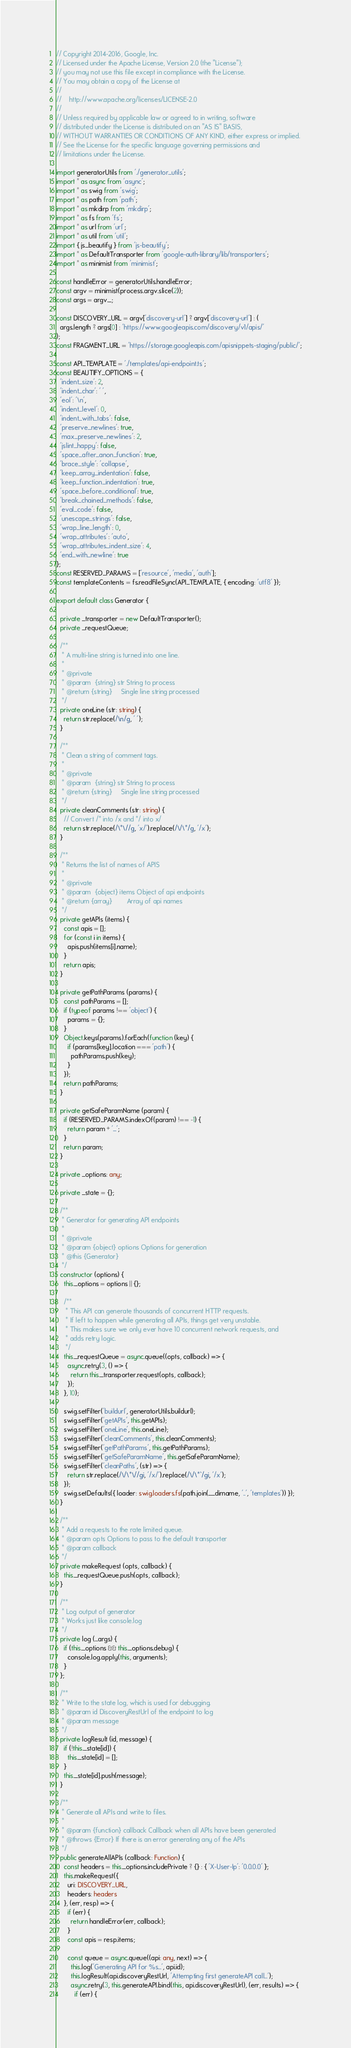Convert code to text. <code><loc_0><loc_0><loc_500><loc_500><_TypeScript_>// Copyright 2014-2016, Google, Inc.
// Licensed under the Apache License, Version 2.0 (the "License");
// you may not use this file except in compliance with the License.
// You may obtain a copy of the License at
//
//    http://www.apache.org/licenses/LICENSE-2.0
//
// Unless required by applicable law or agreed to in writing, software
// distributed under the License is distributed on an "AS IS" BASIS,
// WITHOUT WARRANTIES OR CONDITIONS OF ANY KIND, either express or implied.
// See the License for the specific language governing permissions and
// limitations under the License.

import generatorUtils from './generator_utils';
import * as async from 'async';
import * as swig from 'swig';
import * as path from 'path';
import * as mkdirp from 'mkdirp';
import * as fs from 'fs';
import * as url from 'url';
import * as util from 'util';
import { js_beautify } from 'js-beautify';
import * as DefaultTransporter from 'google-auth-library/lib/transporters';
import * as minimist from 'minimist';

const handleError = generatorUtils.handleError;
const argv = minimist(process.argv.slice(2));
const args = argv._;

const DISCOVERY_URL = argv['discovery-url'] ? argv['discovery-url'] : (
  args.length ? args[0] : 'https://www.googleapis.com/discovery/v1/apis/'
);
const FRAGMENT_URL = 'https://storage.googleapis.com/apisnippets-staging/public/';

const API_TEMPLATE = './templates/api-endpoint.ts';
const BEAUTIFY_OPTIONS = {
  'indent_size': 2,
  'indent_char': ' ',
  'eol': '\n',
  'indent_level': 0,
  'indent_with_tabs': false,
  'preserve_newlines': true,
  'max_preserve_newlines': 2,
  'jslint_happy': false,
  'space_after_anon_function': true,
  'brace_style': 'collapse',
  'keep_array_indentation': false,
  'keep_function_indentation': true,
  'space_before_conditional': true,
  'break_chained_methods': false,
  'eval_code': false,
  'unescape_strings': false,
  'wrap_line_length': 0,
  'wrap_attributes': 'auto',
  'wrap_attributes_indent_size': 4,
  'end_with_newline': true
};
const RESERVED_PARAMS = ['resource', 'media', 'auth'];
const templateContents = fs.readFileSync(API_TEMPLATE, { encoding: 'utf8' });

export default class Generator {

  private _transporter = new DefaultTransporter();
  private _requestQueue;

  /**
   * A multi-line string is turned into one line.
   *
   * @private
   * @param  {string} str String to process
   * @return {string}     Single line string processed
   */
  private oneLine (str: string) {
    return str.replace(/\n/g, ' ');
  }

  /**
   * Clean a string of comment tags.
   *
   * @private
   * @param  {string} str String to process
   * @return {string}     Single line string processed
   */
  private cleanComments (str: string) {
    // Convert /* into /x and */ into x/
    return str.replace(/\*\//g, 'x/').replace(/\/\*/g, '/x');
  }

  /**
   * Returns the list of names of APIS
   *
   * @private
   * @param  {object} items Object of api endpoints
   * @return {array}        Array of api names
   */
  private getAPIs (items) {
    const apis = [];
    for (const i in items) {
      apis.push(items[i].name);
    }
    return apis;
  }

  private getPathParams (params) {
    const pathParams = [];
    if (typeof params !== 'object') {
      params = {};
    }
    Object.keys(params).forEach(function (key) {
      if (params[key].location === 'path') {
        pathParams.push(key);
      }
    });
    return pathParams;
  }

  private getSafeParamName (param) {
    if (RESERVED_PARAMS.indexOf(param) !== -1) {
      return param + '_';
    }
    return param;
  }

  private _options: any;

  private _state = {};

  /**
   * Generator for generating API endpoints
   *
   * @private
   * @param {object} options Options for generation
   * @this {Generator}
   */
  constructor (options) {
    this._options = options || {};
    
    /**
     * This API can generate thousands of concurrent HTTP requests.  
     * If left to happen while generating all APIs, things get very unstable.  
     * This makes sure we only ever have 10 concurrent network requests, and 
     * adds retry logic. 
     */
    this._requestQueue = async.queue((opts, callback) => {
      async.retry(3, () => {
        return this._transporter.request(opts, callback);
      });
    }, 10);

    swig.setFilter('buildurl', generatorUtils.buildurl);
    swig.setFilter('getAPIs', this.getAPIs);
    swig.setFilter('oneLine', this.oneLine);
    swig.setFilter('cleanComments', this.cleanComments);
    swig.setFilter('getPathParams', this.getPathParams);
    swig.setFilter('getSafeParamName', this.getSafeParamName);
    swig.setFilter('cleanPaths', (str) => {
      return str.replace(/\/\*\//gi, '/x/').replace(/\/\*`/gi, '/x');
    });
    swig.setDefaults({ loader: swig.loaders.fs(path.join(__dirname, '..', 'templates')) });
  }

  /**
   * Add a requests to the rate limited queue. 
   * @param opts Options to pass to the default transporter
   * @param callback 
   */
  private makeRequest (opts, callback) {
    this._requestQueue.push(opts, callback);
  } 

  /**
   * Log output of generator
   * Works just like console.log
   */
  private log (...args) {
    if (this._options && this._options.debug) {
      console.log.apply(this, arguments);
    }
  };

  /**
   * Write to the state log, which is used for debugging.  
   * @param id DiscoveryRestUrl of the endpoint to log
   * @param message 
   */
  private logResult (id, message) {
    if (!this._state[id]) {
      this._state[id] = [];
    }
    this._state[id].push(message);
  }

  /**
   * Generate all APIs and write to files.
   *
   * @param {function} callback Callback when all APIs have been generated
   * @throws {Error} If there is an error generating any of the APIs
   */
  public generateAllAPIs (callback: Function) {
    const headers = this._options.includePrivate ? {} : { 'X-User-Ip': '0.0.0.0' };
    this.makeRequest({
      uri: DISCOVERY_URL,
      headers: headers
    }, (err, resp) => {
      if (err) {
        return handleError(err, callback);
      }
      const apis = resp.items;

      const queue = async.queue((api: any, next) => {
        this.log('Generating API for %s...', api.id);
        this.logResult(api.discoveryRestUrl, 'Attempting first generateAPI call...');
        async.retry(3, this.generateAPI.bind(this, api.discoveryRestUrl), (err, results) => {
          if (err) {</code> 